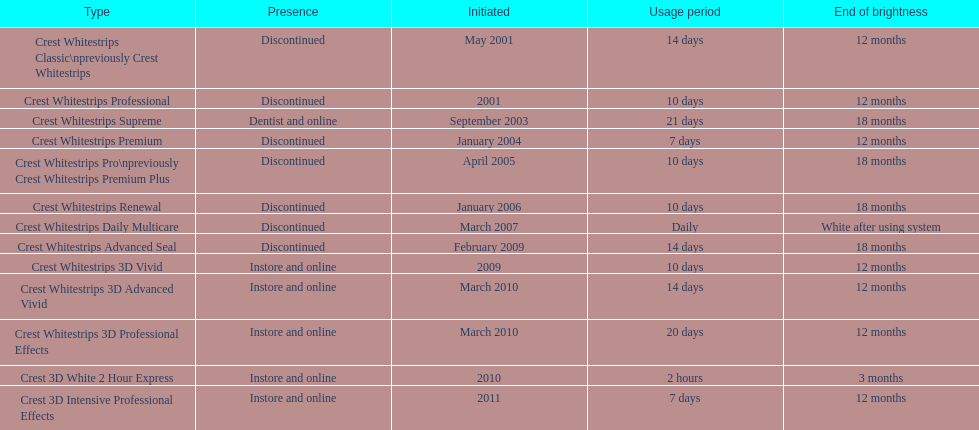Can the crest white strips pro maintain their effectiveness for as long as the crest white strips renewal? Yes. 